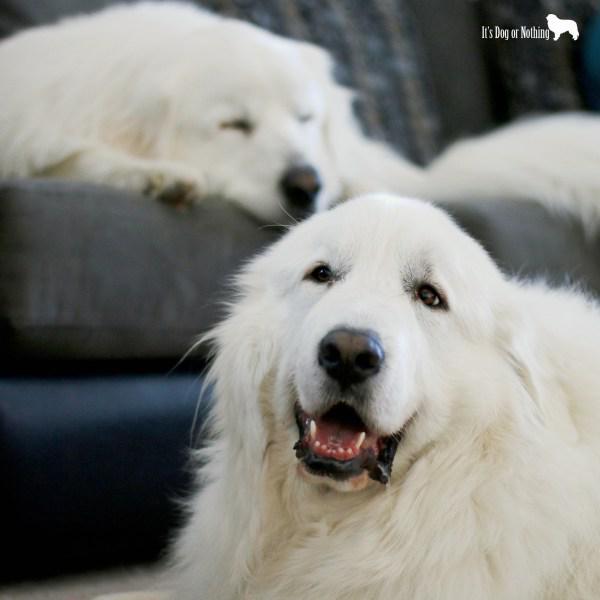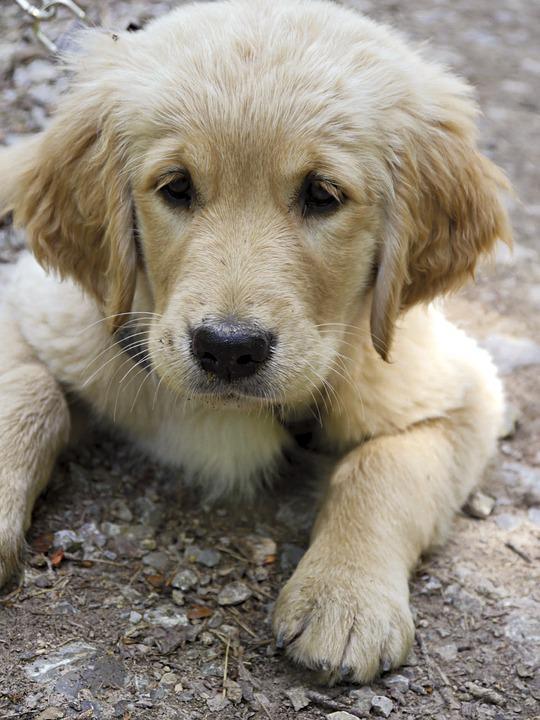The first image is the image on the left, the second image is the image on the right. For the images displayed, is the sentence "there is one dog in the left side pic" factually correct? Answer yes or no. No. The first image is the image on the left, the second image is the image on the right. For the images shown, is this caption "There are exactly two dogs." true? Answer yes or no. No. 